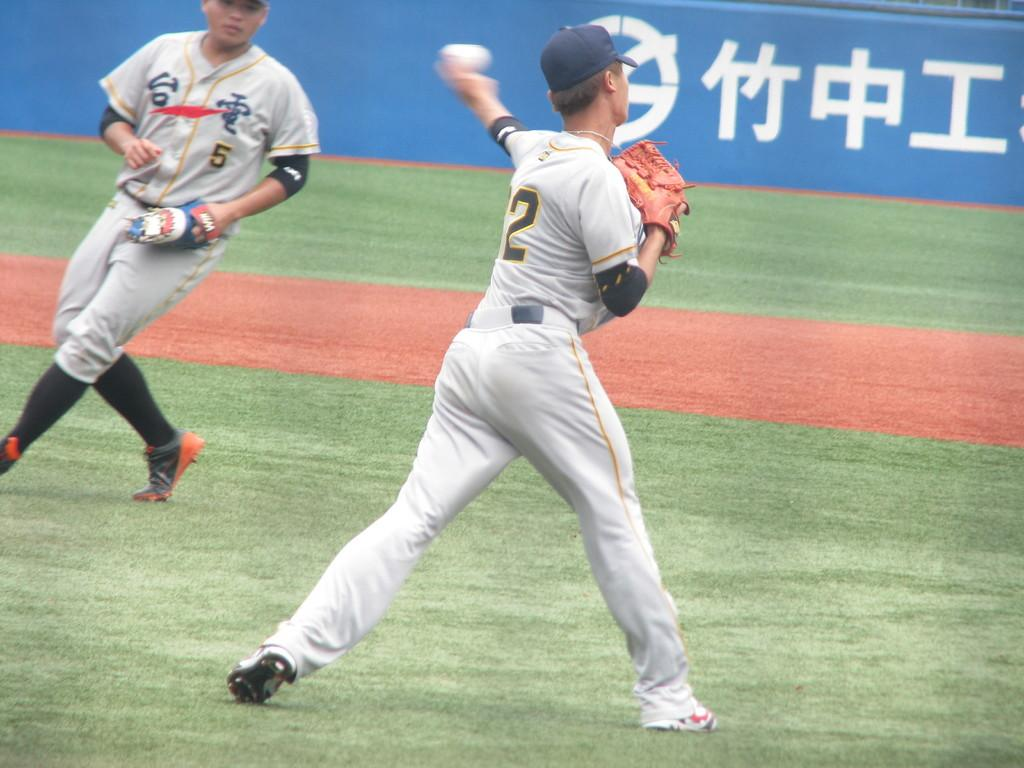<image>
Give a short and clear explanation of the subsequent image. Player number two is throwing the ball to number 5. 